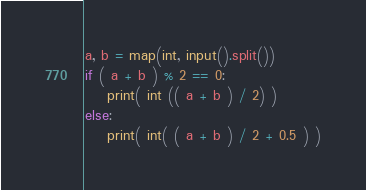Convert code to text. <code><loc_0><loc_0><loc_500><loc_500><_Python_>a, b = map(int, input().split())
if ( a + b ) % 2 == 0:
    print( int (( a + b ) / 2) )
else:
    print( int( ( a + b ) / 2 + 0.5 ) )</code> 